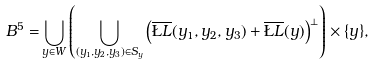<formula> <loc_0><loc_0><loc_500><loc_500>B ^ { 5 } = & \bigcup _ { y \in W } \left ( \bigcup _ { ( y _ { 1 } , y _ { 2 } , y _ { 3 } ) \in S _ { y } } \left ( \overline { \L L } ( y _ { 1 } , y _ { 2 } , y _ { 3 } ) + \overline { \L L } ( y ) \right ) ^ { \perp } \right ) \times \{ y \} ,</formula> 